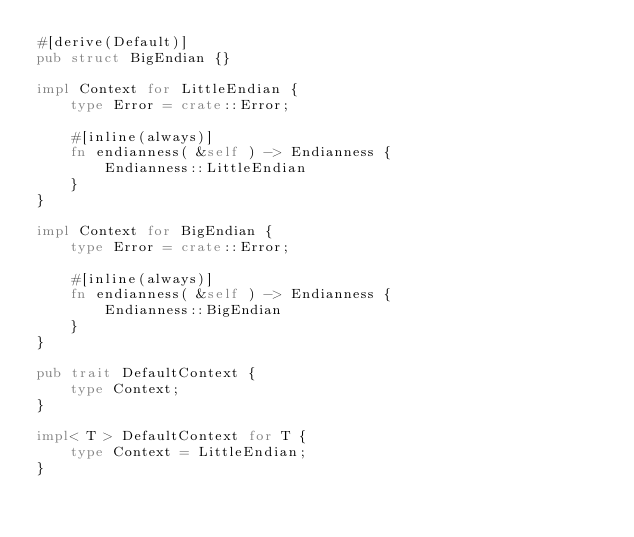<code> <loc_0><loc_0><loc_500><loc_500><_Rust_>#[derive(Default)]
pub struct BigEndian {}

impl Context for LittleEndian {
    type Error = crate::Error;

    #[inline(always)]
    fn endianness( &self ) -> Endianness {
        Endianness::LittleEndian
    }
}

impl Context for BigEndian {
    type Error = crate::Error;

    #[inline(always)]
    fn endianness( &self ) -> Endianness {
        Endianness::BigEndian
    }
}

pub trait DefaultContext {
    type Context;
}

impl< T > DefaultContext for T {
    type Context = LittleEndian;
}
</code> 